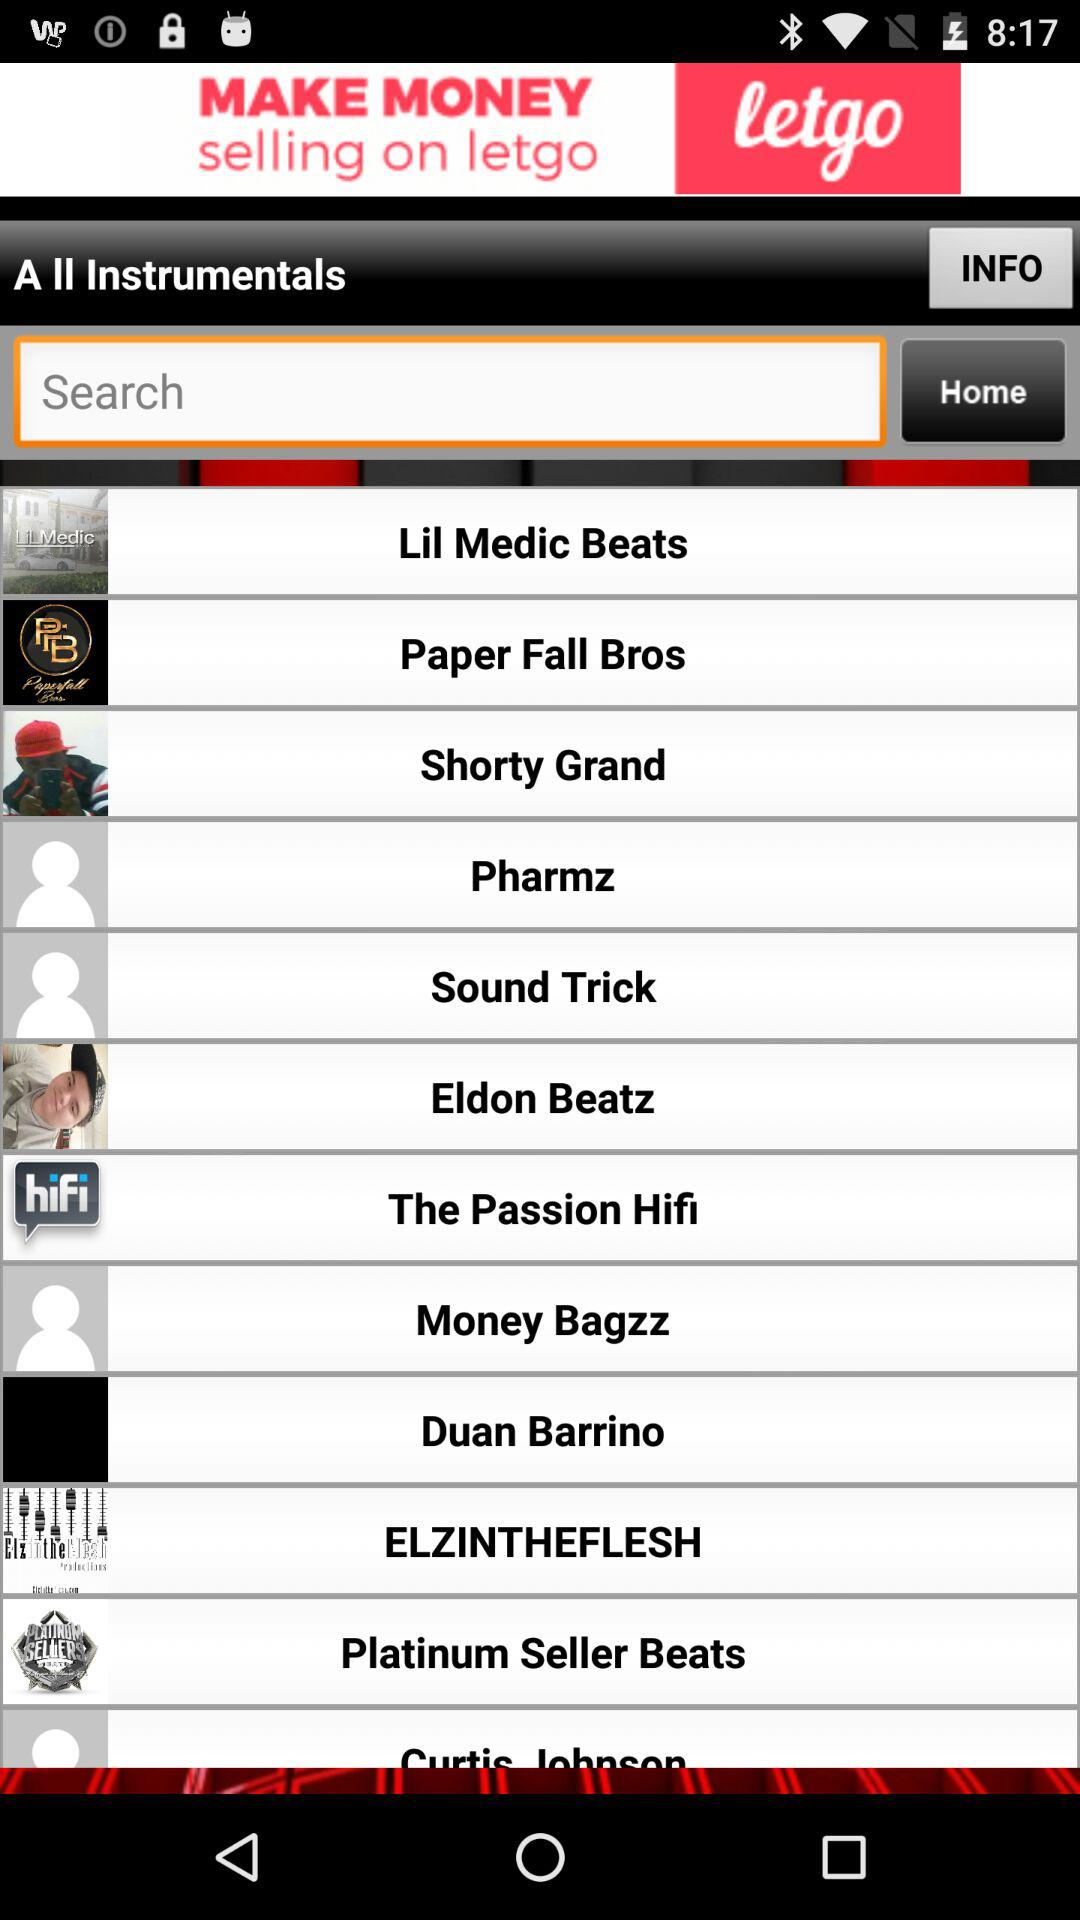What is the name of the application? The name of the application is Letgo. 